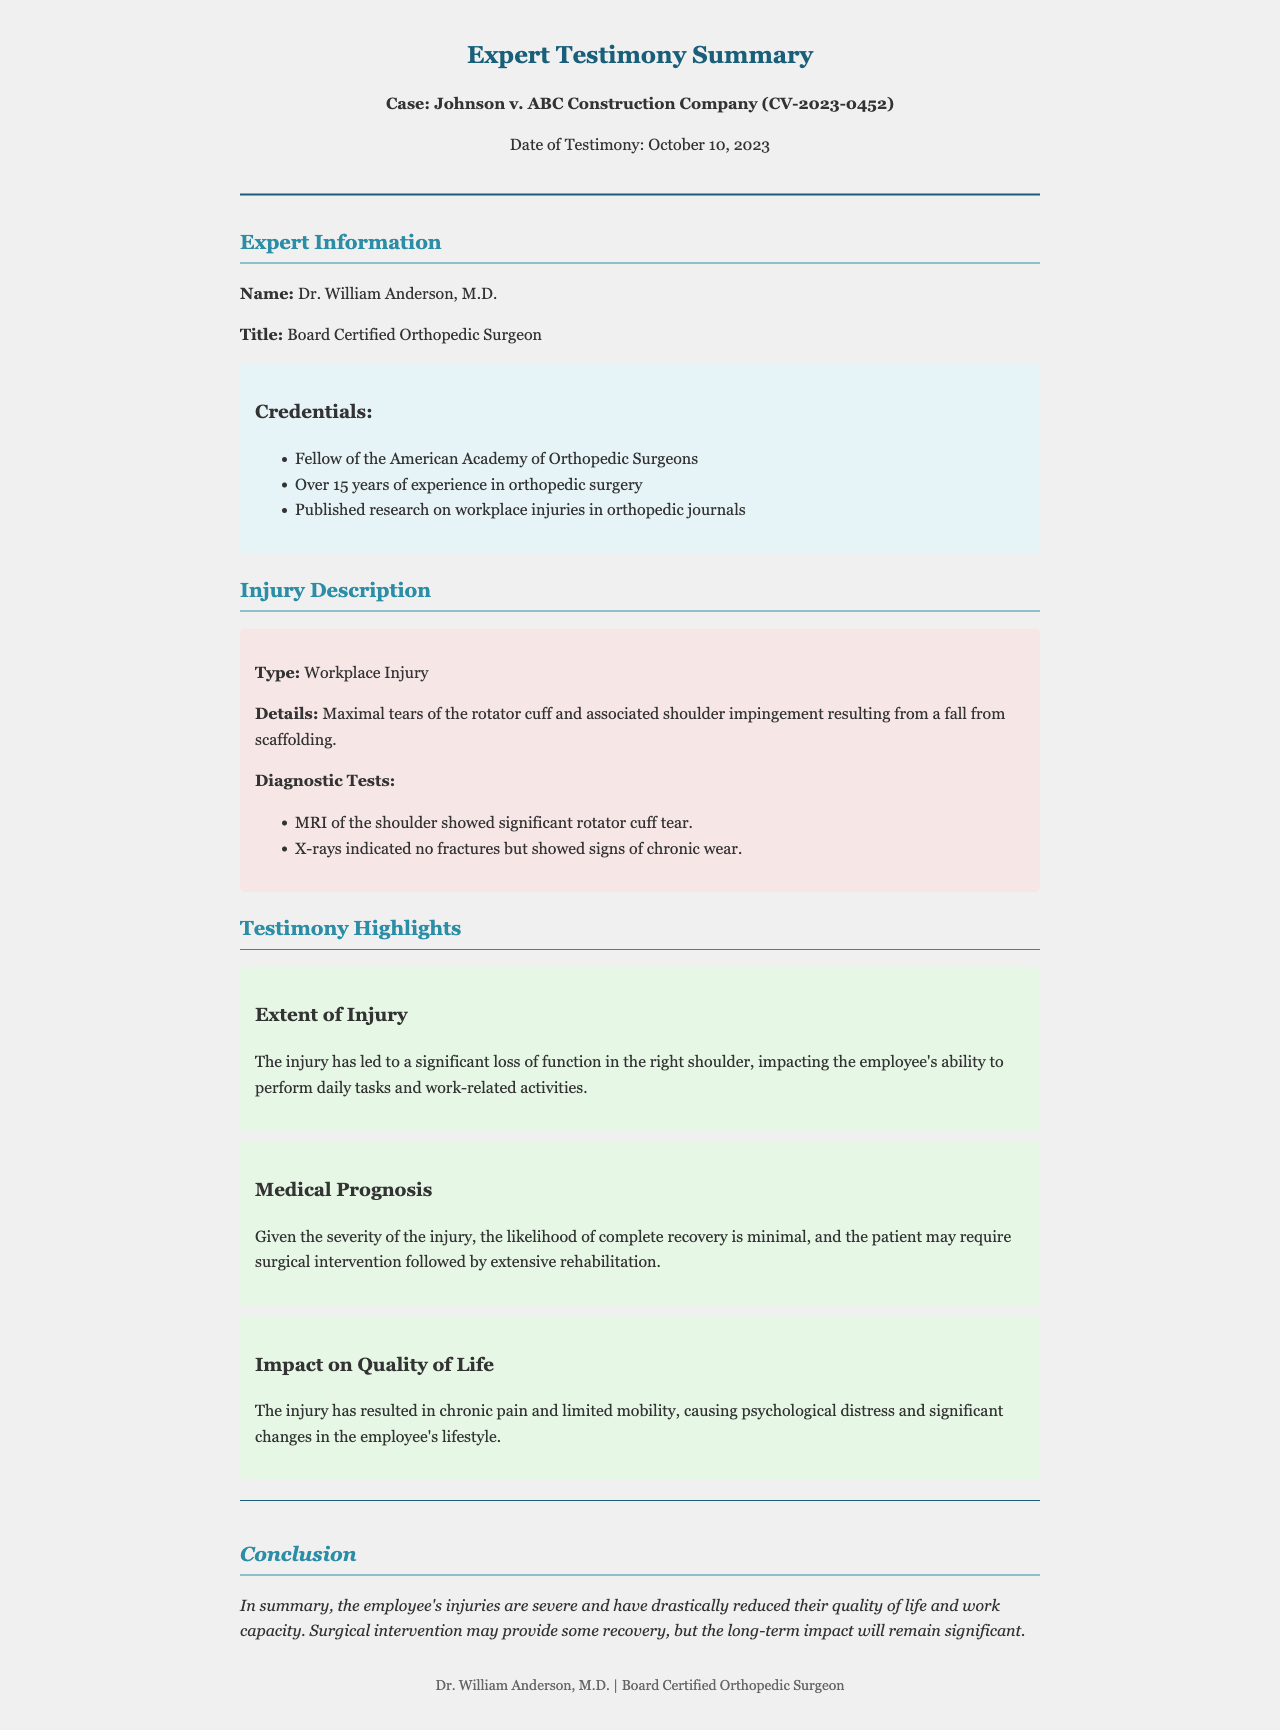What is the case name? The case name is mentioned in the letterhead at the start of the document.
Answer: Johnson v. ABC Construction Company Who provided the expert testimony? The expert's name is clearly listed under Expert Information in the document.
Answer: Dr. William Anderson What type of injury is described? The injury type is highlighted in the Injury Description section of the document.
Answer: Workplace Injury What does the MRI show? The result from the MRI assessment is detailed in the injury description.
Answer: Significant rotator cuff tear What is the prognosis regarding recovery? The prognosis is discussed in the Medical Prognosis highlight section.
Answer: Minimal How has the injury impacted the employee's life? The impact of the injury is summarized in the Impact on Quality of Life highlight.
Answer: Chronic pain and limited mobility How long has Dr. Anderson been practicing? The duration of Dr. Anderson's experience is specified in the Credentials section.
Answer: Over 15 years What condition was indicated by the X-rays? The condition observed in the X-ray results is mentioned in the Injury Description section.
Answer: Signs of chronic wear What is the conclusion regarding the employee's injuries? The conclusion summarizes the overall effects of the injuries, found at the end of the document.
Answer: Severe and have drastically reduced their quality of life and work capacity 